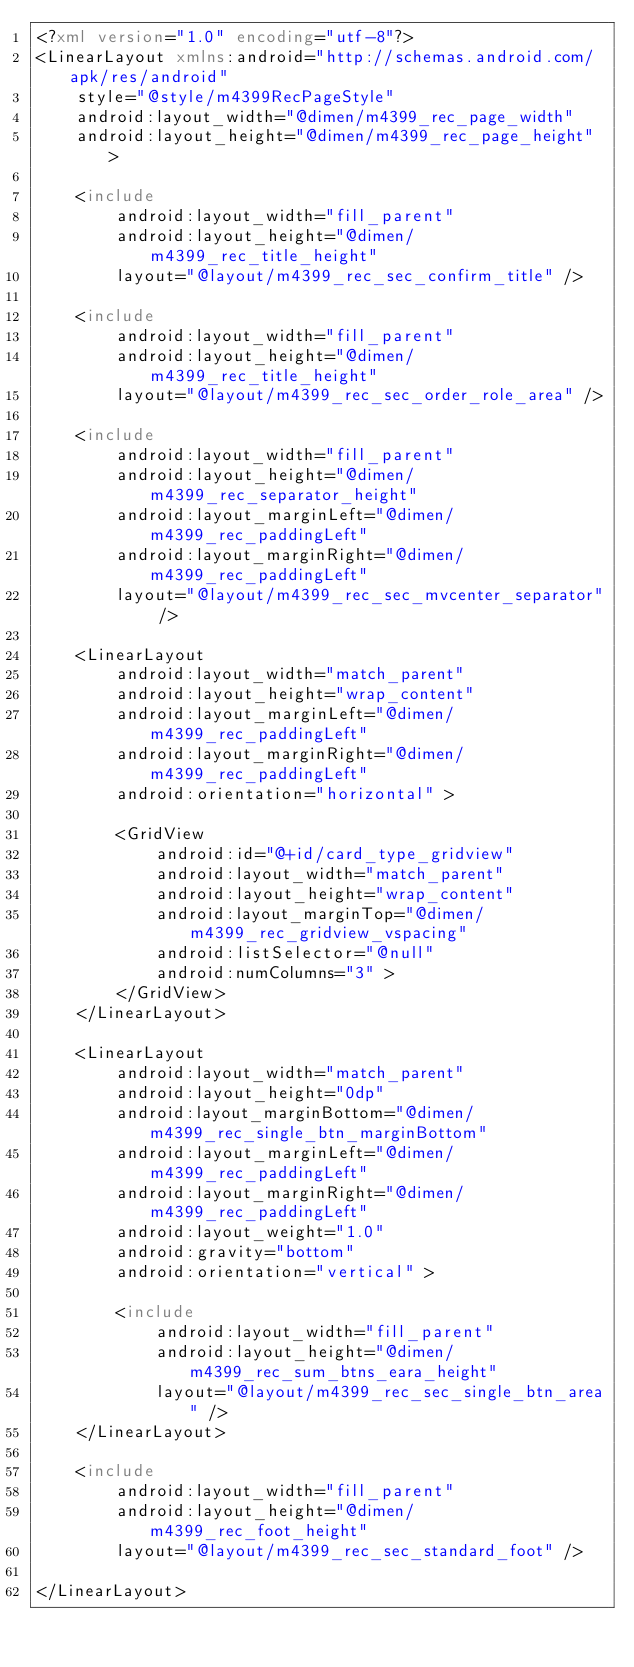<code> <loc_0><loc_0><loc_500><loc_500><_XML_><?xml version="1.0" encoding="utf-8"?>
<LinearLayout xmlns:android="http://schemas.android.com/apk/res/android"
    style="@style/m4399RecPageStyle"
    android:layout_width="@dimen/m4399_rec_page_width"
    android:layout_height="@dimen/m4399_rec_page_height" >

    <include
        android:layout_width="fill_parent"
        android:layout_height="@dimen/m4399_rec_title_height"
        layout="@layout/m4399_rec_sec_confirm_title" />

    <include
        android:layout_width="fill_parent"
        android:layout_height="@dimen/m4399_rec_title_height"
        layout="@layout/m4399_rec_sec_order_role_area" />

    <include
        android:layout_width="fill_parent"
        android:layout_height="@dimen/m4399_rec_separator_height"
        android:layout_marginLeft="@dimen/m4399_rec_paddingLeft"
        android:layout_marginRight="@dimen/m4399_rec_paddingLeft"
        layout="@layout/m4399_rec_sec_mvcenter_separator" />

    <LinearLayout
        android:layout_width="match_parent"
        android:layout_height="wrap_content"
        android:layout_marginLeft="@dimen/m4399_rec_paddingLeft"
        android:layout_marginRight="@dimen/m4399_rec_paddingLeft"
        android:orientation="horizontal" >

        <GridView
            android:id="@+id/card_type_gridview"
            android:layout_width="match_parent"
            android:layout_height="wrap_content"
            android:layout_marginTop="@dimen/m4399_rec_gridview_vspacing"
            android:listSelector="@null"
            android:numColumns="3" >
        </GridView>
    </LinearLayout>

    <LinearLayout
        android:layout_width="match_parent"
        android:layout_height="0dp"
        android:layout_marginBottom="@dimen/m4399_rec_single_btn_marginBottom"
        android:layout_marginLeft="@dimen/m4399_rec_paddingLeft"
        android:layout_marginRight="@dimen/m4399_rec_paddingLeft"
        android:layout_weight="1.0"
        android:gravity="bottom"
        android:orientation="vertical" >

        <include
            android:layout_width="fill_parent"
            android:layout_height="@dimen/m4399_rec_sum_btns_eara_height"
            layout="@layout/m4399_rec_sec_single_btn_area" />
    </LinearLayout>

    <include
        android:layout_width="fill_parent"
        android:layout_height="@dimen/m4399_rec_foot_height"
        layout="@layout/m4399_rec_sec_standard_foot" />

</LinearLayout></code> 